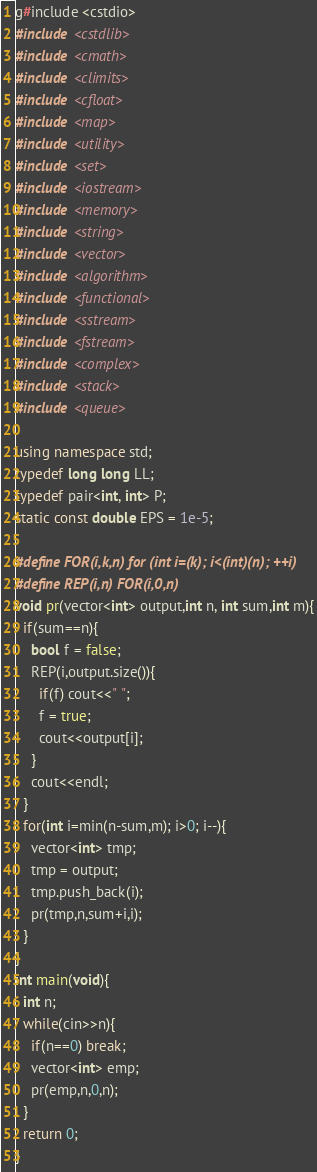Convert code to text. <code><loc_0><loc_0><loc_500><loc_500><_C++_>g#include <cstdio>
#include <cstdlib>
#include <cmath>
#include <climits>
#include <cfloat>
#include <map>
#include <utility>
#include <set>
#include <iostream>
#include <memory>
#include <string>
#include <vector>
#include <algorithm>
#include <functional>
#include <sstream>
#include <fstream>
#include <complex>
#include <stack>
#include <queue>

using namespace std;
typedef long long LL;
typedef pair<int, int> P;
static const double EPS = 1e-5;

#define FOR(i,k,n) for (int i=(k); i<(int)(n); ++i)
#define REP(i,n) FOR(i,0,n)
void pr(vector<int> output,int n, int sum,int m){
  if(sum==n){
    bool f = false;
    REP(i,output.size()){
      if(f) cout<<" ";
      f = true;
      cout<<output[i];
    }
    cout<<endl;
  }
  for(int i=min(n-sum,m); i>0; i--){
    vector<int> tmp;
    tmp = output;
    tmp.push_back(i);
    pr(tmp,n,sum+i,i);
  }
}
int main(void){
  int n;
  while(cin>>n){
    if(n==0) break;
    vector<int> emp;
    pr(emp,n,0,n);
  }   
  return 0;
}</code> 